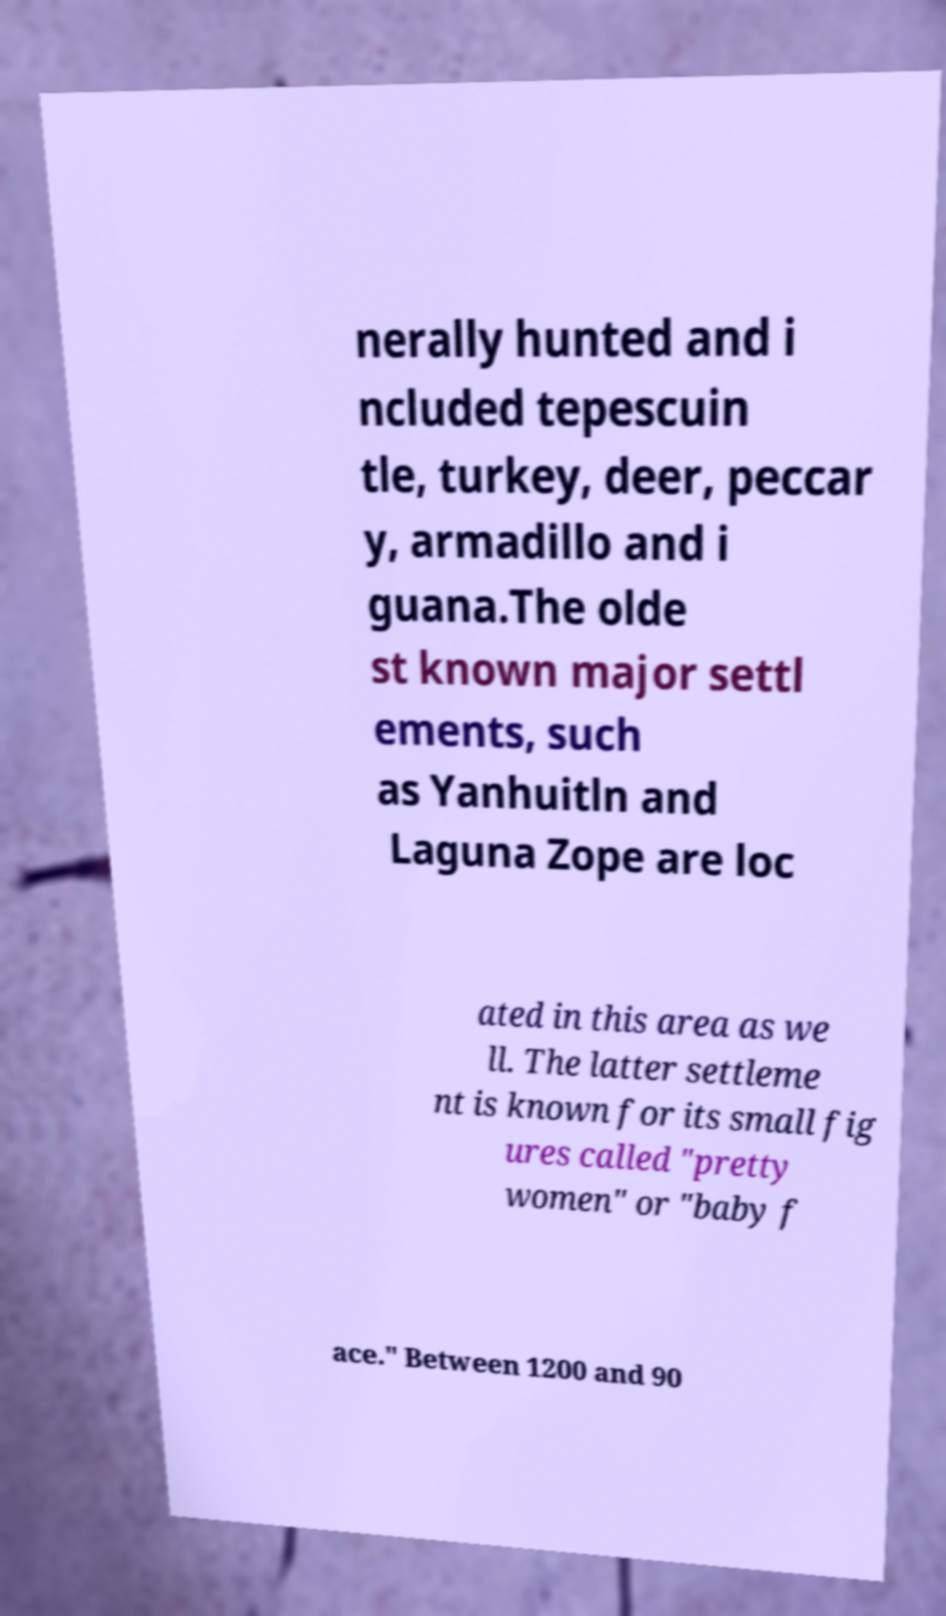What messages or text are displayed in this image? I need them in a readable, typed format. nerally hunted and i ncluded tepescuin tle, turkey, deer, peccar y, armadillo and i guana.The olde st known major settl ements, such as Yanhuitln and Laguna Zope are loc ated in this area as we ll. The latter settleme nt is known for its small fig ures called "pretty women" or "baby f ace." Between 1200 and 90 